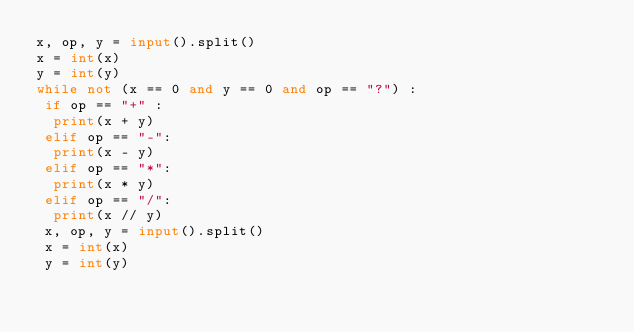<code> <loc_0><loc_0><loc_500><loc_500><_Python_>x, op, y = input().split()
x = int(x)
y = int(y)
while not (x == 0 and y == 0 and op == "?") :
 if op == "+" :
  print(x + y)
 elif op == "-":
  print(x - y)
 elif op == "*":
  print(x * y)
 elif op == "/":
  print(x // y)
 x, op, y = input().split()
 x = int(x)
 y = int(y)</code> 